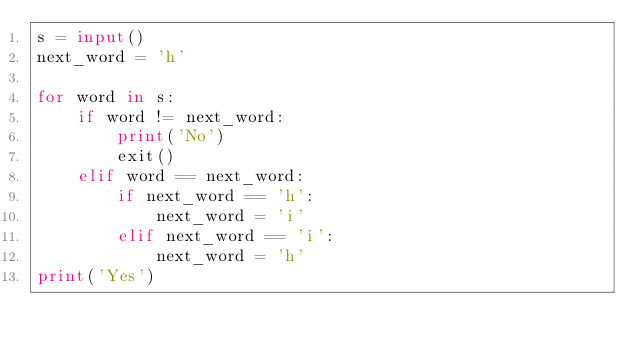Convert code to text. <code><loc_0><loc_0><loc_500><loc_500><_Python_>s = input()
next_word = 'h'

for word in s:
    if word != next_word:
        print('No')
        exit()
    elif word == next_word:
        if next_word == 'h':
            next_word = 'i'
        elif next_word == 'i':
            next_word = 'h'
print('Yes')
</code> 